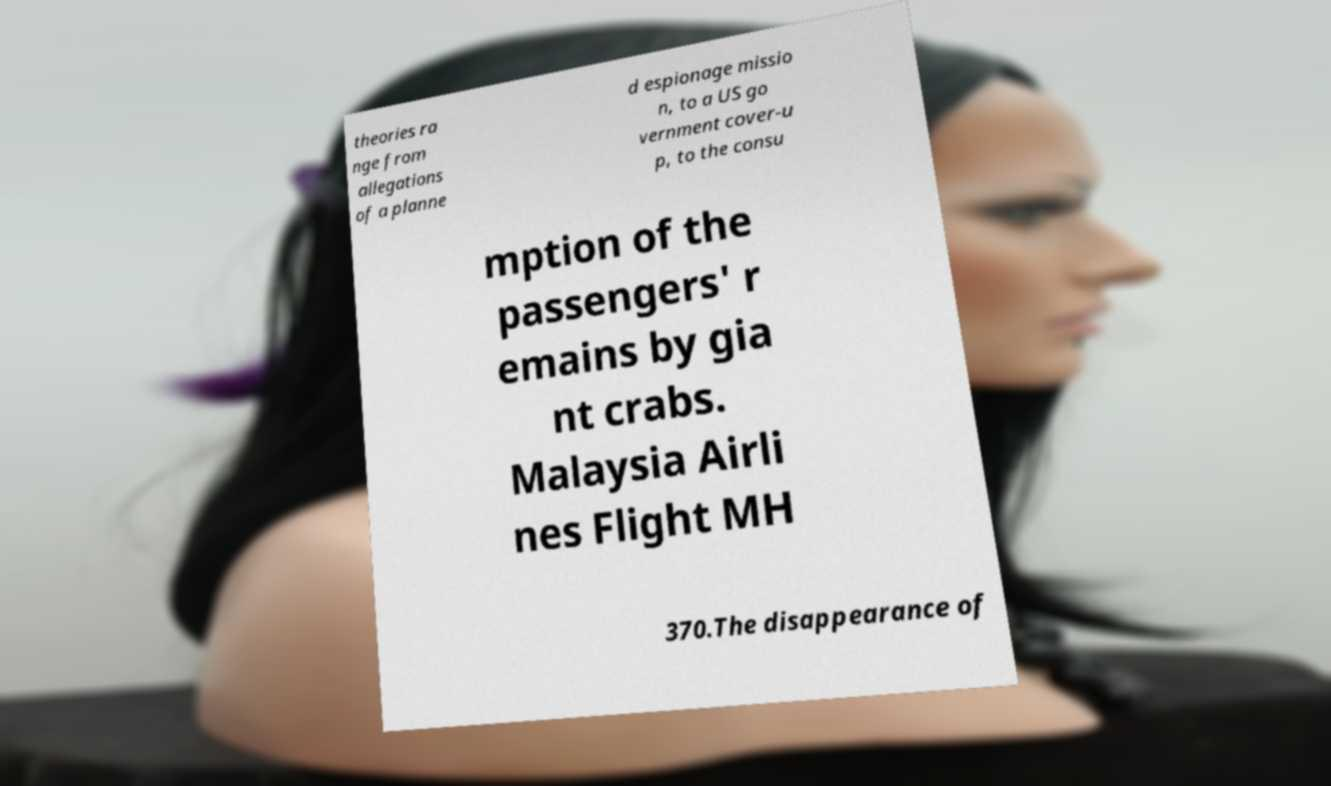What messages or text are displayed in this image? I need them in a readable, typed format. theories ra nge from allegations of a planne d espionage missio n, to a US go vernment cover-u p, to the consu mption of the passengers' r emains by gia nt crabs. Malaysia Airli nes Flight MH 370.The disappearance of 